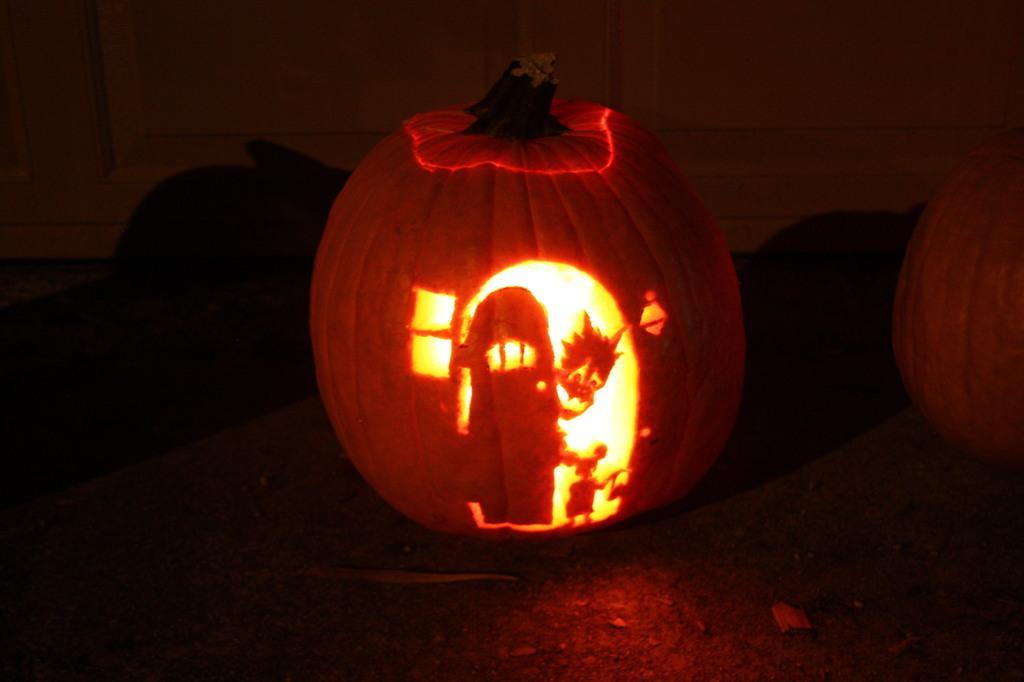How would you summarize this image in a sentence or two? Here in this picture we can see a hand carved pumpkin with a light in it present on the table over there and beside it also we can see a pumpkin present over there. 